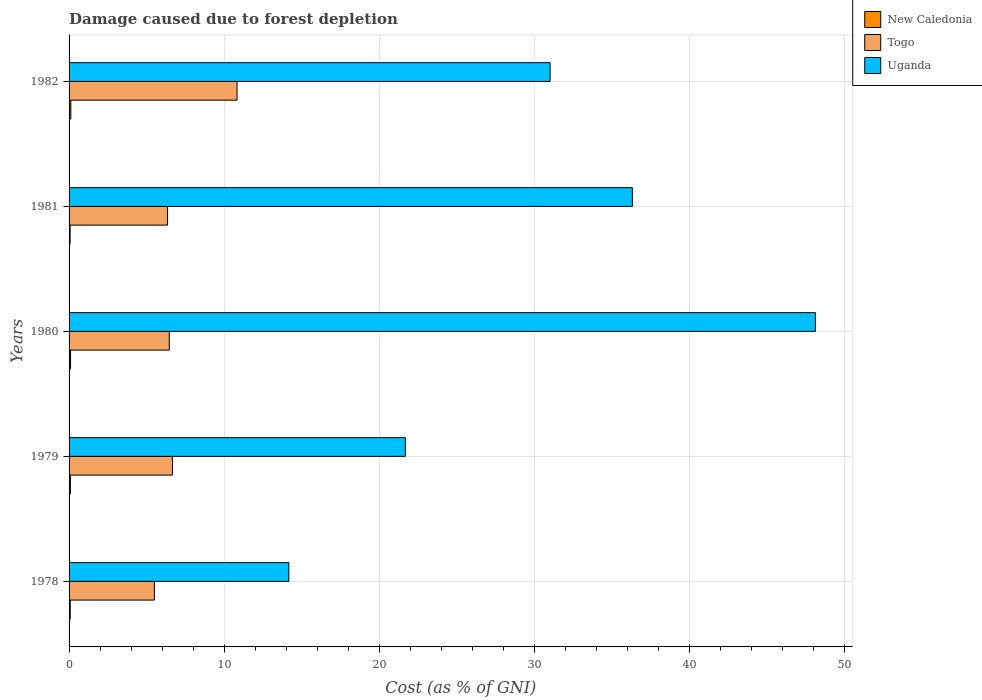How many different coloured bars are there?
Your answer should be compact. 3. How many groups of bars are there?
Give a very brief answer. 5. Are the number of bars on each tick of the Y-axis equal?
Offer a very short reply. Yes. What is the label of the 4th group of bars from the top?
Keep it short and to the point. 1979. What is the cost of damage caused due to forest depletion in Uganda in 1979?
Your answer should be very brief. 21.68. Across all years, what is the maximum cost of damage caused due to forest depletion in New Caledonia?
Your response must be concise. 0.11. Across all years, what is the minimum cost of damage caused due to forest depletion in Uganda?
Provide a succinct answer. 14.17. In which year was the cost of damage caused due to forest depletion in Togo minimum?
Give a very brief answer. 1978. What is the total cost of damage caused due to forest depletion in New Caledonia in the graph?
Keep it short and to the point. 0.44. What is the difference between the cost of damage caused due to forest depletion in Togo in 1979 and that in 1980?
Make the answer very short. 0.2. What is the difference between the cost of damage caused due to forest depletion in New Caledonia in 1981 and the cost of damage caused due to forest depletion in Uganda in 1982?
Your answer should be compact. -30.94. What is the average cost of damage caused due to forest depletion in Uganda per year?
Keep it short and to the point. 30.26. In the year 1982, what is the difference between the cost of damage caused due to forest depletion in Togo and cost of damage caused due to forest depletion in Uganda?
Give a very brief answer. -20.18. In how many years, is the cost of damage caused due to forest depletion in Uganda greater than 8 %?
Keep it short and to the point. 5. What is the ratio of the cost of damage caused due to forest depletion in New Caledonia in 1978 to that in 1981?
Keep it short and to the point. 1.13. Is the cost of damage caused due to forest depletion in Uganda in 1978 less than that in 1979?
Keep it short and to the point. Yes. Is the difference between the cost of damage caused due to forest depletion in Togo in 1979 and 1980 greater than the difference between the cost of damage caused due to forest depletion in Uganda in 1979 and 1980?
Your answer should be very brief. Yes. What is the difference between the highest and the second highest cost of damage caused due to forest depletion in Uganda?
Your answer should be compact. 11.8. What is the difference between the highest and the lowest cost of damage caused due to forest depletion in Togo?
Ensure brevity in your answer.  5.33. In how many years, is the cost of damage caused due to forest depletion in Togo greater than the average cost of damage caused due to forest depletion in Togo taken over all years?
Your response must be concise. 1. What does the 1st bar from the top in 1980 represents?
Offer a terse response. Uganda. What does the 1st bar from the bottom in 1979 represents?
Keep it short and to the point. New Caledonia. How many bars are there?
Make the answer very short. 15. Are all the bars in the graph horizontal?
Your response must be concise. Yes. Does the graph contain any zero values?
Make the answer very short. No. Does the graph contain grids?
Offer a terse response. Yes. Where does the legend appear in the graph?
Provide a short and direct response. Top right. How many legend labels are there?
Offer a very short reply. 3. What is the title of the graph?
Your response must be concise. Damage caused due to forest depletion. What is the label or title of the X-axis?
Your response must be concise. Cost (as % of GNI). What is the label or title of the Y-axis?
Offer a very short reply. Years. What is the Cost (as % of GNI) of New Caledonia in 1978?
Provide a short and direct response. 0.08. What is the Cost (as % of GNI) of Togo in 1978?
Provide a short and direct response. 5.5. What is the Cost (as % of GNI) in Uganda in 1978?
Provide a succinct answer. 14.17. What is the Cost (as % of GNI) in New Caledonia in 1979?
Offer a very short reply. 0.09. What is the Cost (as % of GNI) in Togo in 1979?
Your answer should be compact. 6.66. What is the Cost (as % of GNI) in Uganda in 1979?
Offer a terse response. 21.68. What is the Cost (as % of GNI) in New Caledonia in 1980?
Keep it short and to the point. 0.1. What is the Cost (as % of GNI) in Togo in 1980?
Provide a short and direct response. 6.46. What is the Cost (as % of GNI) in Uganda in 1980?
Provide a succinct answer. 48.11. What is the Cost (as % of GNI) in New Caledonia in 1981?
Give a very brief answer. 0.07. What is the Cost (as % of GNI) of Togo in 1981?
Your response must be concise. 6.35. What is the Cost (as % of GNI) in Uganda in 1981?
Offer a very short reply. 36.31. What is the Cost (as % of GNI) of New Caledonia in 1982?
Make the answer very short. 0.11. What is the Cost (as % of GNI) in Togo in 1982?
Ensure brevity in your answer.  10.83. What is the Cost (as % of GNI) in Uganda in 1982?
Provide a succinct answer. 31.01. Across all years, what is the maximum Cost (as % of GNI) of New Caledonia?
Keep it short and to the point. 0.11. Across all years, what is the maximum Cost (as % of GNI) in Togo?
Your response must be concise. 10.83. Across all years, what is the maximum Cost (as % of GNI) of Uganda?
Make the answer very short. 48.11. Across all years, what is the minimum Cost (as % of GNI) of New Caledonia?
Your response must be concise. 0.07. Across all years, what is the minimum Cost (as % of GNI) of Togo?
Give a very brief answer. 5.5. Across all years, what is the minimum Cost (as % of GNI) of Uganda?
Keep it short and to the point. 14.17. What is the total Cost (as % of GNI) in New Caledonia in the graph?
Offer a very short reply. 0.44. What is the total Cost (as % of GNI) in Togo in the graph?
Keep it short and to the point. 35.8. What is the total Cost (as % of GNI) in Uganda in the graph?
Offer a very short reply. 151.28. What is the difference between the Cost (as % of GNI) in New Caledonia in 1978 and that in 1979?
Give a very brief answer. -0.01. What is the difference between the Cost (as % of GNI) in Togo in 1978 and that in 1979?
Give a very brief answer. -1.16. What is the difference between the Cost (as % of GNI) of Uganda in 1978 and that in 1979?
Your answer should be very brief. -7.51. What is the difference between the Cost (as % of GNI) in New Caledonia in 1978 and that in 1980?
Your answer should be compact. -0.02. What is the difference between the Cost (as % of GNI) in Togo in 1978 and that in 1980?
Ensure brevity in your answer.  -0.96. What is the difference between the Cost (as % of GNI) of Uganda in 1978 and that in 1980?
Make the answer very short. -33.95. What is the difference between the Cost (as % of GNI) of New Caledonia in 1978 and that in 1981?
Your answer should be very brief. 0.01. What is the difference between the Cost (as % of GNI) of Togo in 1978 and that in 1981?
Your answer should be compact. -0.85. What is the difference between the Cost (as % of GNI) of Uganda in 1978 and that in 1981?
Your response must be concise. -22.14. What is the difference between the Cost (as % of GNI) in New Caledonia in 1978 and that in 1982?
Your answer should be very brief. -0.04. What is the difference between the Cost (as % of GNI) of Togo in 1978 and that in 1982?
Provide a short and direct response. -5.33. What is the difference between the Cost (as % of GNI) of Uganda in 1978 and that in 1982?
Keep it short and to the point. -16.84. What is the difference between the Cost (as % of GNI) of New Caledonia in 1979 and that in 1980?
Your answer should be very brief. -0.01. What is the difference between the Cost (as % of GNI) in Togo in 1979 and that in 1980?
Your response must be concise. 0.2. What is the difference between the Cost (as % of GNI) in Uganda in 1979 and that in 1980?
Give a very brief answer. -26.43. What is the difference between the Cost (as % of GNI) of New Caledonia in 1979 and that in 1981?
Ensure brevity in your answer.  0.02. What is the difference between the Cost (as % of GNI) in Togo in 1979 and that in 1981?
Give a very brief answer. 0.32. What is the difference between the Cost (as % of GNI) in Uganda in 1979 and that in 1981?
Ensure brevity in your answer.  -14.63. What is the difference between the Cost (as % of GNI) in New Caledonia in 1979 and that in 1982?
Provide a short and direct response. -0.03. What is the difference between the Cost (as % of GNI) of Togo in 1979 and that in 1982?
Give a very brief answer. -4.16. What is the difference between the Cost (as % of GNI) in Uganda in 1979 and that in 1982?
Your answer should be compact. -9.33. What is the difference between the Cost (as % of GNI) of New Caledonia in 1980 and that in 1981?
Make the answer very short. 0.03. What is the difference between the Cost (as % of GNI) in Togo in 1980 and that in 1981?
Give a very brief answer. 0.11. What is the difference between the Cost (as % of GNI) in Uganda in 1980 and that in 1981?
Your answer should be very brief. 11.8. What is the difference between the Cost (as % of GNI) in New Caledonia in 1980 and that in 1982?
Keep it short and to the point. -0.02. What is the difference between the Cost (as % of GNI) of Togo in 1980 and that in 1982?
Your response must be concise. -4.37. What is the difference between the Cost (as % of GNI) in Uganda in 1980 and that in 1982?
Provide a short and direct response. 17.1. What is the difference between the Cost (as % of GNI) in New Caledonia in 1981 and that in 1982?
Keep it short and to the point. -0.05. What is the difference between the Cost (as % of GNI) in Togo in 1981 and that in 1982?
Offer a terse response. -4.48. What is the difference between the Cost (as % of GNI) of Uganda in 1981 and that in 1982?
Give a very brief answer. 5.3. What is the difference between the Cost (as % of GNI) of New Caledonia in 1978 and the Cost (as % of GNI) of Togo in 1979?
Your answer should be very brief. -6.59. What is the difference between the Cost (as % of GNI) of New Caledonia in 1978 and the Cost (as % of GNI) of Uganda in 1979?
Your answer should be very brief. -21.6. What is the difference between the Cost (as % of GNI) in Togo in 1978 and the Cost (as % of GNI) in Uganda in 1979?
Your response must be concise. -16.18. What is the difference between the Cost (as % of GNI) of New Caledonia in 1978 and the Cost (as % of GNI) of Togo in 1980?
Your answer should be very brief. -6.38. What is the difference between the Cost (as % of GNI) in New Caledonia in 1978 and the Cost (as % of GNI) in Uganda in 1980?
Your answer should be compact. -48.04. What is the difference between the Cost (as % of GNI) in Togo in 1978 and the Cost (as % of GNI) in Uganda in 1980?
Offer a terse response. -42.61. What is the difference between the Cost (as % of GNI) of New Caledonia in 1978 and the Cost (as % of GNI) of Togo in 1981?
Offer a terse response. -6.27. What is the difference between the Cost (as % of GNI) of New Caledonia in 1978 and the Cost (as % of GNI) of Uganda in 1981?
Ensure brevity in your answer.  -36.24. What is the difference between the Cost (as % of GNI) in Togo in 1978 and the Cost (as % of GNI) in Uganda in 1981?
Ensure brevity in your answer.  -30.81. What is the difference between the Cost (as % of GNI) in New Caledonia in 1978 and the Cost (as % of GNI) in Togo in 1982?
Your answer should be compact. -10.75. What is the difference between the Cost (as % of GNI) in New Caledonia in 1978 and the Cost (as % of GNI) in Uganda in 1982?
Ensure brevity in your answer.  -30.93. What is the difference between the Cost (as % of GNI) in Togo in 1978 and the Cost (as % of GNI) in Uganda in 1982?
Ensure brevity in your answer.  -25.51. What is the difference between the Cost (as % of GNI) in New Caledonia in 1979 and the Cost (as % of GNI) in Togo in 1980?
Offer a terse response. -6.37. What is the difference between the Cost (as % of GNI) of New Caledonia in 1979 and the Cost (as % of GNI) of Uganda in 1980?
Your answer should be compact. -48.03. What is the difference between the Cost (as % of GNI) in Togo in 1979 and the Cost (as % of GNI) in Uganda in 1980?
Your answer should be very brief. -41.45. What is the difference between the Cost (as % of GNI) of New Caledonia in 1979 and the Cost (as % of GNI) of Togo in 1981?
Give a very brief answer. -6.26. What is the difference between the Cost (as % of GNI) in New Caledonia in 1979 and the Cost (as % of GNI) in Uganda in 1981?
Your answer should be very brief. -36.23. What is the difference between the Cost (as % of GNI) of Togo in 1979 and the Cost (as % of GNI) of Uganda in 1981?
Your answer should be very brief. -29.65. What is the difference between the Cost (as % of GNI) of New Caledonia in 1979 and the Cost (as % of GNI) of Togo in 1982?
Your answer should be very brief. -10.74. What is the difference between the Cost (as % of GNI) in New Caledonia in 1979 and the Cost (as % of GNI) in Uganda in 1982?
Ensure brevity in your answer.  -30.92. What is the difference between the Cost (as % of GNI) of Togo in 1979 and the Cost (as % of GNI) of Uganda in 1982?
Give a very brief answer. -24.35. What is the difference between the Cost (as % of GNI) in New Caledonia in 1980 and the Cost (as % of GNI) in Togo in 1981?
Provide a succinct answer. -6.25. What is the difference between the Cost (as % of GNI) of New Caledonia in 1980 and the Cost (as % of GNI) of Uganda in 1981?
Your answer should be compact. -36.22. What is the difference between the Cost (as % of GNI) of Togo in 1980 and the Cost (as % of GNI) of Uganda in 1981?
Give a very brief answer. -29.85. What is the difference between the Cost (as % of GNI) in New Caledonia in 1980 and the Cost (as % of GNI) in Togo in 1982?
Provide a succinct answer. -10.73. What is the difference between the Cost (as % of GNI) of New Caledonia in 1980 and the Cost (as % of GNI) of Uganda in 1982?
Give a very brief answer. -30.91. What is the difference between the Cost (as % of GNI) of Togo in 1980 and the Cost (as % of GNI) of Uganda in 1982?
Provide a short and direct response. -24.55. What is the difference between the Cost (as % of GNI) in New Caledonia in 1981 and the Cost (as % of GNI) in Togo in 1982?
Ensure brevity in your answer.  -10.76. What is the difference between the Cost (as % of GNI) in New Caledonia in 1981 and the Cost (as % of GNI) in Uganda in 1982?
Give a very brief answer. -30.94. What is the difference between the Cost (as % of GNI) of Togo in 1981 and the Cost (as % of GNI) of Uganda in 1982?
Keep it short and to the point. -24.66. What is the average Cost (as % of GNI) of New Caledonia per year?
Give a very brief answer. 0.09. What is the average Cost (as % of GNI) of Togo per year?
Keep it short and to the point. 7.16. What is the average Cost (as % of GNI) of Uganda per year?
Your answer should be compact. 30.26. In the year 1978, what is the difference between the Cost (as % of GNI) in New Caledonia and Cost (as % of GNI) in Togo?
Provide a short and direct response. -5.42. In the year 1978, what is the difference between the Cost (as % of GNI) in New Caledonia and Cost (as % of GNI) in Uganda?
Provide a short and direct response. -14.09. In the year 1978, what is the difference between the Cost (as % of GNI) in Togo and Cost (as % of GNI) in Uganda?
Provide a short and direct response. -8.67. In the year 1979, what is the difference between the Cost (as % of GNI) of New Caledonia and Cost (as % of GNI) of Togo?
Ensure brevity in your answer.  -6.58. In the year 1979, what is the difference between the Cost (as % of GNI) of New Caledonia and Cost (as % of GNI) of Uganda?
Your response must be concise. -21.59. In the year 1979, what is the difference between the Cost (as % of GNI) in Togo and Cost (as % of GNI) in Uganda?
Your answer should be compact. -15.02. In the year 1980, what is the difference between the Cost (as % of GNI) of New Caledonia and Cost (as % of GNI) of Togo?
Make the answer very short. -6.36. In the year 1980, what is the difference between the Cost (as % of GNI) in New Caledonia and Cost (as % of GNI) in Uganda?
Offer a terse response. -48.02. In the year 1980, what is the difference between the Cost (as % of GNI) in Togo and Cost (as % of GNI) in Uganda?
Your answer should be very brief. -41.65. In the year 1981, what is the difference between the Cost (as % of GNI) of New Caledonia and Cost (as % of GNI) of Togo?
Keep it short and to the point. -6.28. In the year 1981, what is the difference between the Cost (as % of GNI) in New Caledonia and Cost (as % of GNI) in Uganda?
Your response must be concise. -36.25. In the year 1981, what is the difference between the Cost (as % of GNI) of Togo and Cost (as % of GNI) of Uganda?
Give a very brief answer. -29.97. In the year 1982, what is the difference between the Cost (as % of GNI) of New Caledonia and Cost (as % of GNI) of Togo?
Make the answer very short. -10.71. In the year 1982, what is the difference between the Cost (as % of GNI) of New Caledonia and Cost (as % of GNI) of Uganda?
Give a very brief answer. -30.9. In the year 1982, what is the difference between the Cost (as % of GNI) in Togo and Cost (as % of GNI) in Uganda?
Offer a terse response. -20.18. What is the ratio of the Cost (as % of GNI) of New Caledonia in 1978 to that in 1979?
Make the answer very short. 0.88. What is the ratio of the Cost (as % of GNI) of Togo in 1978 to that in 1979?
Keep it short and to the point. 0.83. What is the ratio of the Cost (as % of GNI) of Uganda in 1978 to that in 1979?
Give a very brief answer. 0.65. What is the ratio of the Cost (as % of GNI) in New Caledonia in 1978 to that in 1980?
Ensure brevity in your answer.  0.79. What is the ratio of the Cost (as % of GNI) in Togo in 1978 to that in 1980?
Provide a succinct answer. 0.85. What is the ratio of the Cost (as % of GNI) in Uganda in 1978 to that in 1980?
Provide a short and direct response. 0.29. What is the ratio of the Cost (as % of GNI) of New Caledonia in 1978 to that in 1981?
Offer a terse response. 1.13. What is the ratio of the Cost (as % of GNI) in Togo in 1978 to that in 1981?
Offer a terse response. 0.87. What is the ratio of the Cost (as % of GNI) in Uganda in 1978 to that in 1981?
Keep it short and to the point. 0.39. What is the ratio of the Cost (as % of GNI) of New Caledonia in 1978 to that in 1982?
Provide a succinct answer. 0.66. What is the ratio of the Cost (as % of GNI) of Togo in 1978 to that in 1982?
Give a very brief answer. 0.51. What is the ratio of the Cost (as % of GNI) in Uganda in 1978 to that in 1982?
Offer a very short reply. 0.46. What is the ratio of the Cost (as % of GNI) of New Caledonia in 1979 to that in 1980?
Keep it short and to the point. 0.9. What is the ratio of the Cost (as % of GNI) of Togo in 1979 to that in 1980?
Provide a succinct answer. 1.03. What is the ratio of the Cost (as % of GNI) in Uganda in 1979 to that in 1980?
Provide a succinct answer. 0.45. What is the ratio of the Cost (as % of GNI) of New Caledonia in 1979 to that in 1981?
Keep it short and to the point. 1.28. What is the ratio of the Cost (as % of GNI) in Togo in 1979 to that in 1981?
Keep it short and to the point. 1.05. What is the ratio of the Cost (as % of GNI) of Uganda in 1979 to that in 1981?
Your response must be concise. 0.6. What is the ratio of the Cost (as % of GNI) in New Caledonia in 1979 to that in 1982?
Ensure brevity in your answer.  0.75. What is the ratio of the Cost (as % of GNI) of Togo in 1979 to that in 1982?
Your answer should be compact. 0.62. What is the ratio of the Cost (as % of GNI) in Uganda in 1979 to that in 1982?
Provide a short and direct response. 0.7. What is the ratio of the Cost (as % of GNI) in New Caledonia in 1980 to that in 1981?
Ensure brevity in your answer.  1.43. What is the ratio of the Cost (as % of GNI) in Togo in 1980 to that in 1981?
Provide a short and direct response. 1.02. What is the ratio of the Cost (as % of GNI) of Uganda in 1980 to that in 1981?
Keep it short and to the point. 1.32. What is the ratio of the Cost (as % of GNI) in New Caledonia in 1980 to that in 1982?
Give a very brief answer. 0.84. What is the ratio of the Cost (as % of GNI) of Togo in 1980 to that in 1982?
Ensure brevity in your answer.  0.6. What is the ratio of the Cost (as % of GNI) in Uganda in 1980 to that in 1982?
Provide a short and direct response. 1.55. What is the ratio of the Cost (as % of GNI) in New Caledonia in 1981 to that in 1982?
Provide a succinct answer. 0.59. What is the ratio of the Cost (as % of GNI) in Togo in 1981 to that in 1982?
Your response must be concise. 0.59. What is the ratio of the Cost (as % of GNI) of Uganda in 1981 to that in 1982?
Your answer should be compact. 1.17. What is the difference between the highest and the second highest Cost (as % of GNI) in New Caledonia?
Keep it short and to the point. 0.02. What is the difference between the highest and the second highest Cost (as % of GNI) in Togo?
Make the answer very short. 4.16. What is the difference between the highest and the second highest Cost (as % of GNI) in Uganda?
Ensure brevity in your answer.  11.8. What is the difference between the highest and the lowest Cost (as % of GNI) of New Caledonia?
Make the answer very short. 0.05. What is the difference between the highest and the lowest Cost (as % of GNI) in Togo?
Your answer should be compact. 5.33. What is the difference between the highest and the lowest Cost (as % of GNI) of Uganda?
Your answer should be very brief. 33.95. 